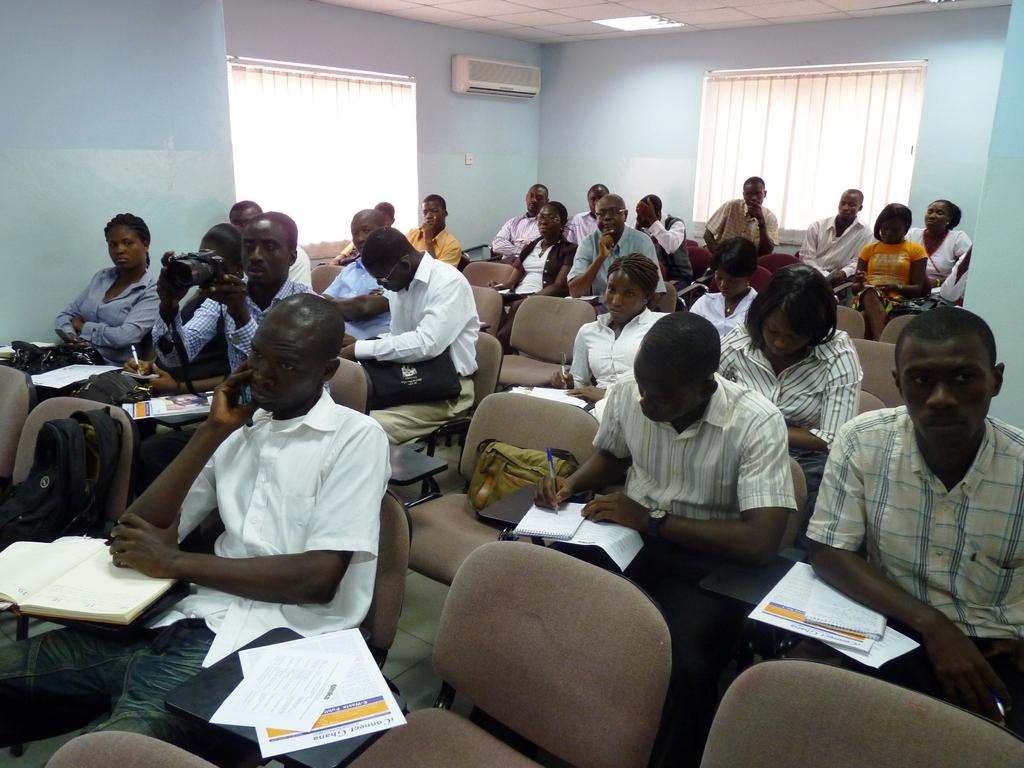How many people are in the image? There is a group of people in the image. What are the people doing in the image? The people are sitting on chairs. What can be seen in the background of the image? There is a curtain and a window in the background of the image. What type of agreement did the people in the image reach? There is no indication in the image of any agreement being reached, as the people are simply sitting on chairs. 